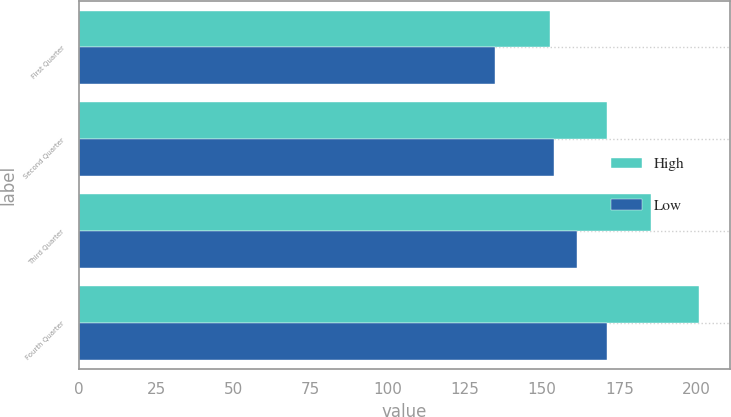<chart> <loc_0><loc_0><loc_500><loc_500><stacked_bar_chart><ecel><fcel>First Quarter<fcel>Second Quarter<fcel>Third Quarter<fcel>Fourth Quarter<nl><fcel>High<fcel>152.51<fcel>170.96<fcel>185.23<fcel>200.86<nl><fcel>Low<fcel>134.87<fcel>153.93<fcel>161.27<fcel>170.99<nl></chart> 